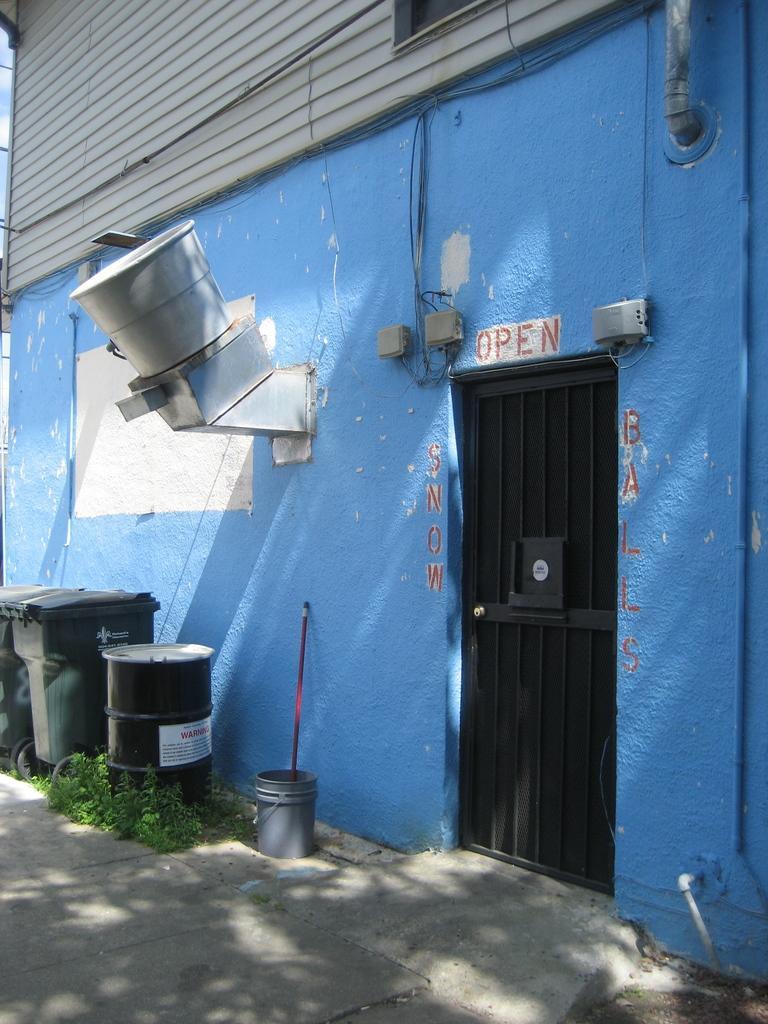How would you summarize this image in a sentence or two? In this image in the center there is one house and a door, on the left side there are some drums containers and one bucket and stick and in the center there is one machine. At the bottom there is a walkway and some grass. 